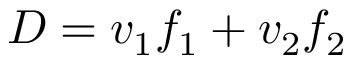<formula> <loc_0><loc_0><loc_500><loc_500>D = v _ { 1 } f _ { 1 } + v _ { 2 } f _ { 2 }</formula> 